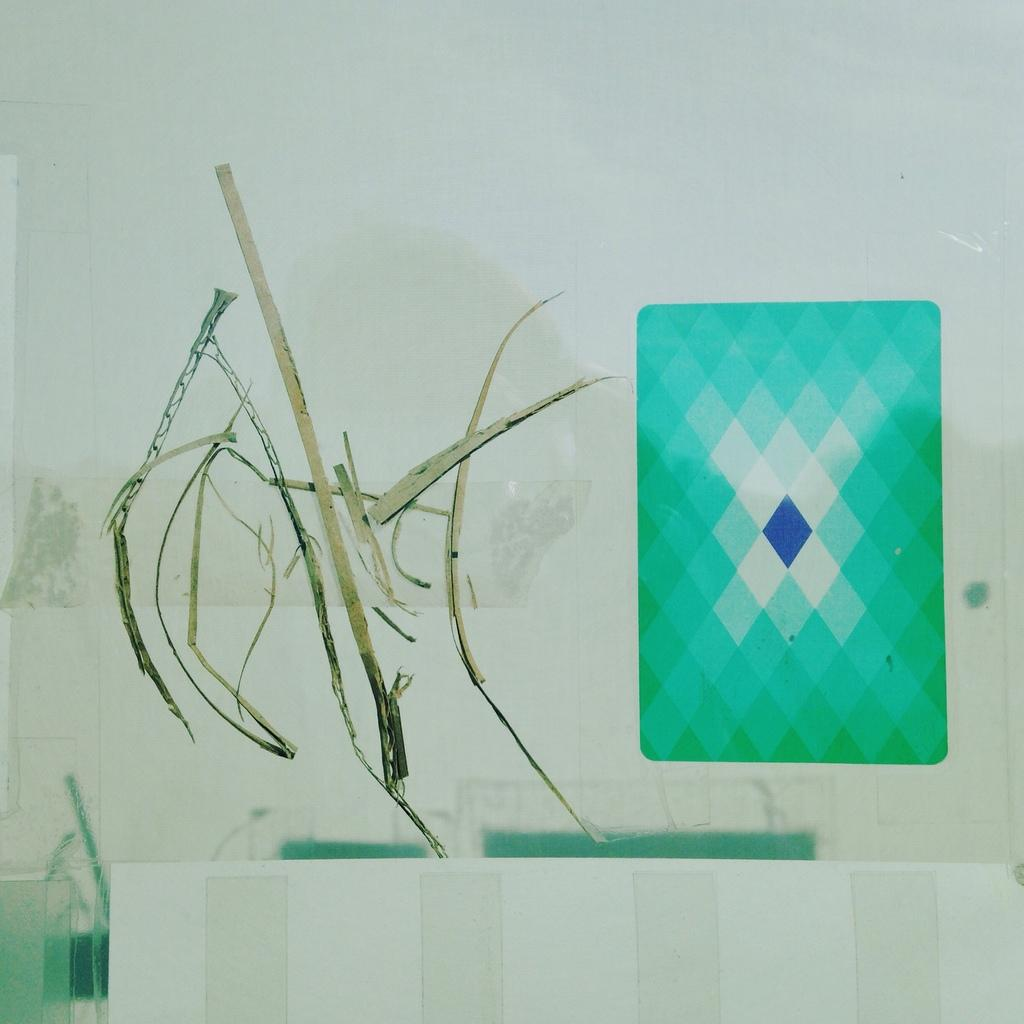What objects can be seen in the image? There are sticks and dried grass in the image. On what surface are the sticks and dried grass placed? The sticks and dried grass are on a glass surface. What colors are present in the image? There is an object in green color and an object in blue color in the image. What is the color of the background in the image? The background of the image is white. How many dogs are present in the image? There are no dogs present in the image. What type of shade is provided by the objects in the image? There is no shade provided by the objects in the image, as they are sticks and dried grass on a glass surface. 